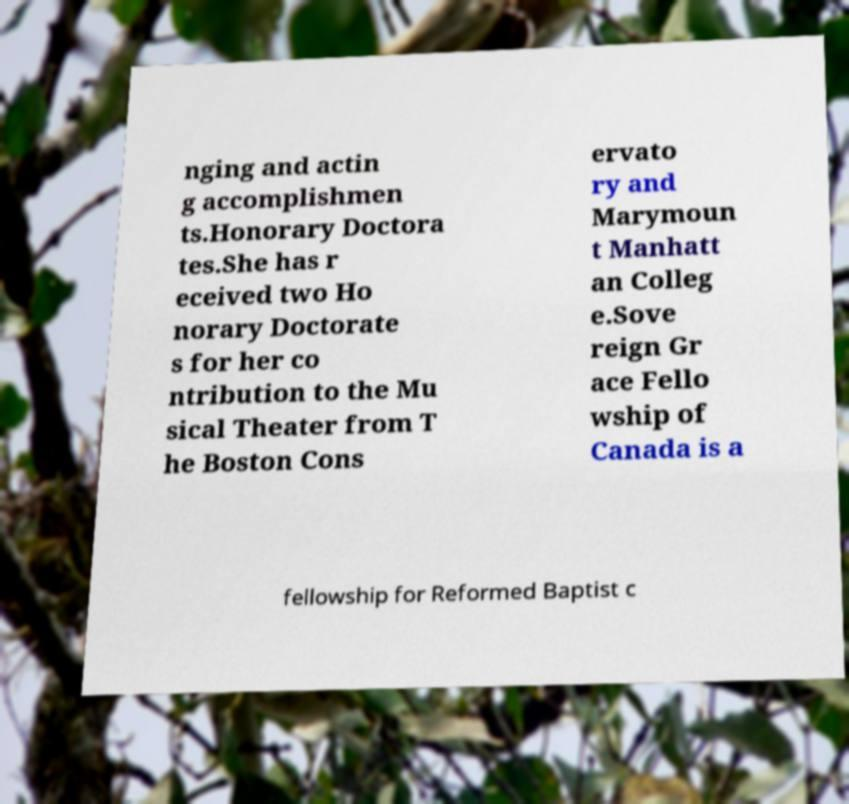Could you extract and type out the text from this image? nging and actin g accomplishmen ts.Honorary Doctora tes.She has r eceived two Ho norary Doctorate s for her co ntribution to the Mu sical Theater from T he Boston Cons ervato ry and Marymoun t Manhatt an Colleg e.Sove reign Gr ace Fello wship of Canada is a fellowship for Reformed Baptist c 